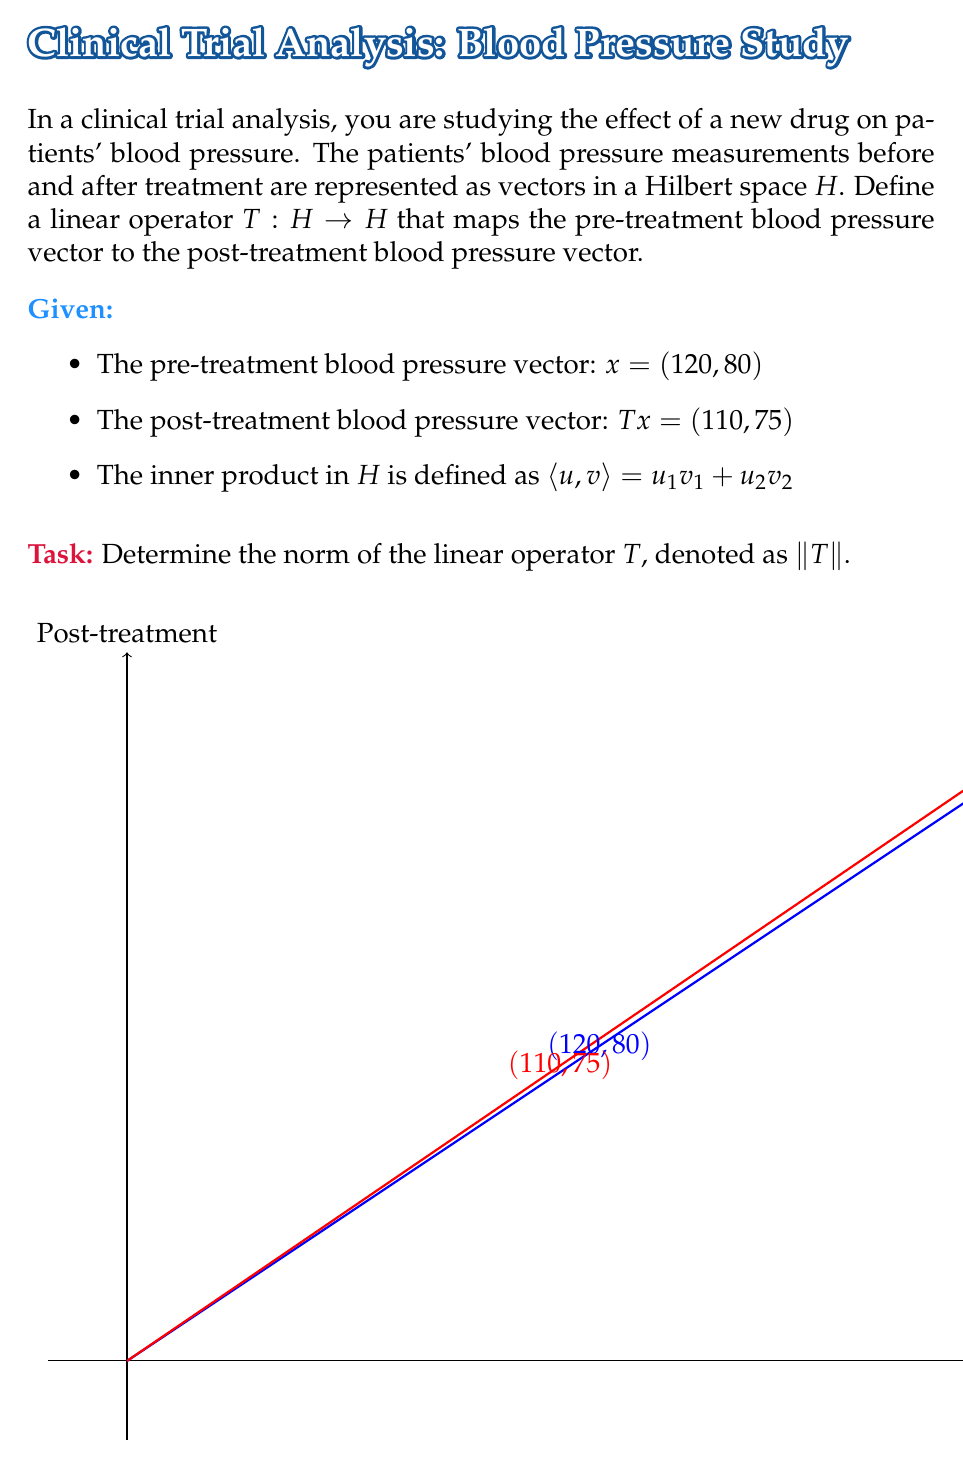Could you help me with this problem? To determine the norm of the linear operator $T$, we'll follow these steps:

1) The norm of a linear operator $T$ in a Hilbert space is defined as:

   $$\|T\| = \sup_{x \neq 0} \frac{\|Tx\|}{\|x\|}$$

2) We're given one pair of vectors: $x$ and $Tx$. Let's calculate their norms:

   $\|x\| = \sqrt{\langle x, x \rangle} = \sqrt{120^2 + 80^2} = \sqrt{20800} \approx 144.22$
   
   $\|Tx\| = \sqrt{\langle Tx, Tx \rangle} = \sqrt{110^2 + 75^2} = \sqrt{18025} \approx 134.26$

3) Now, we can calculate the ratio:

   $$\frac{\|Tx\|}{\|x\|} = \frac{134.26}{144.22} \approx 0.9309$$

4) However, this is just for one vector. The true norm of $T$ is the supremum of this ratio over all non-zero vectors in $H$.

5) To find the supremum, we need to consider the matrix representation of $T$. Given the information, we can deduce that:

   $$T = \begin{pmatrix} 
   \frac{110}{120} & 0 \\
   0 & \frac{75}{80}
   \end{pmatrix} = \begin{pmatrix}
   0.9167 & 0 \\
   0 & 0.9375
   \end{pmatrix}$$

6) For a diagonal matrix, the operator norm is equal to the largest absolute value of its diagonal elements.

Therefore, $\|T\| = \max(0.9167, 0.9375) = 0.9375$.
Answer: $\|T\| = 0.9375$ 